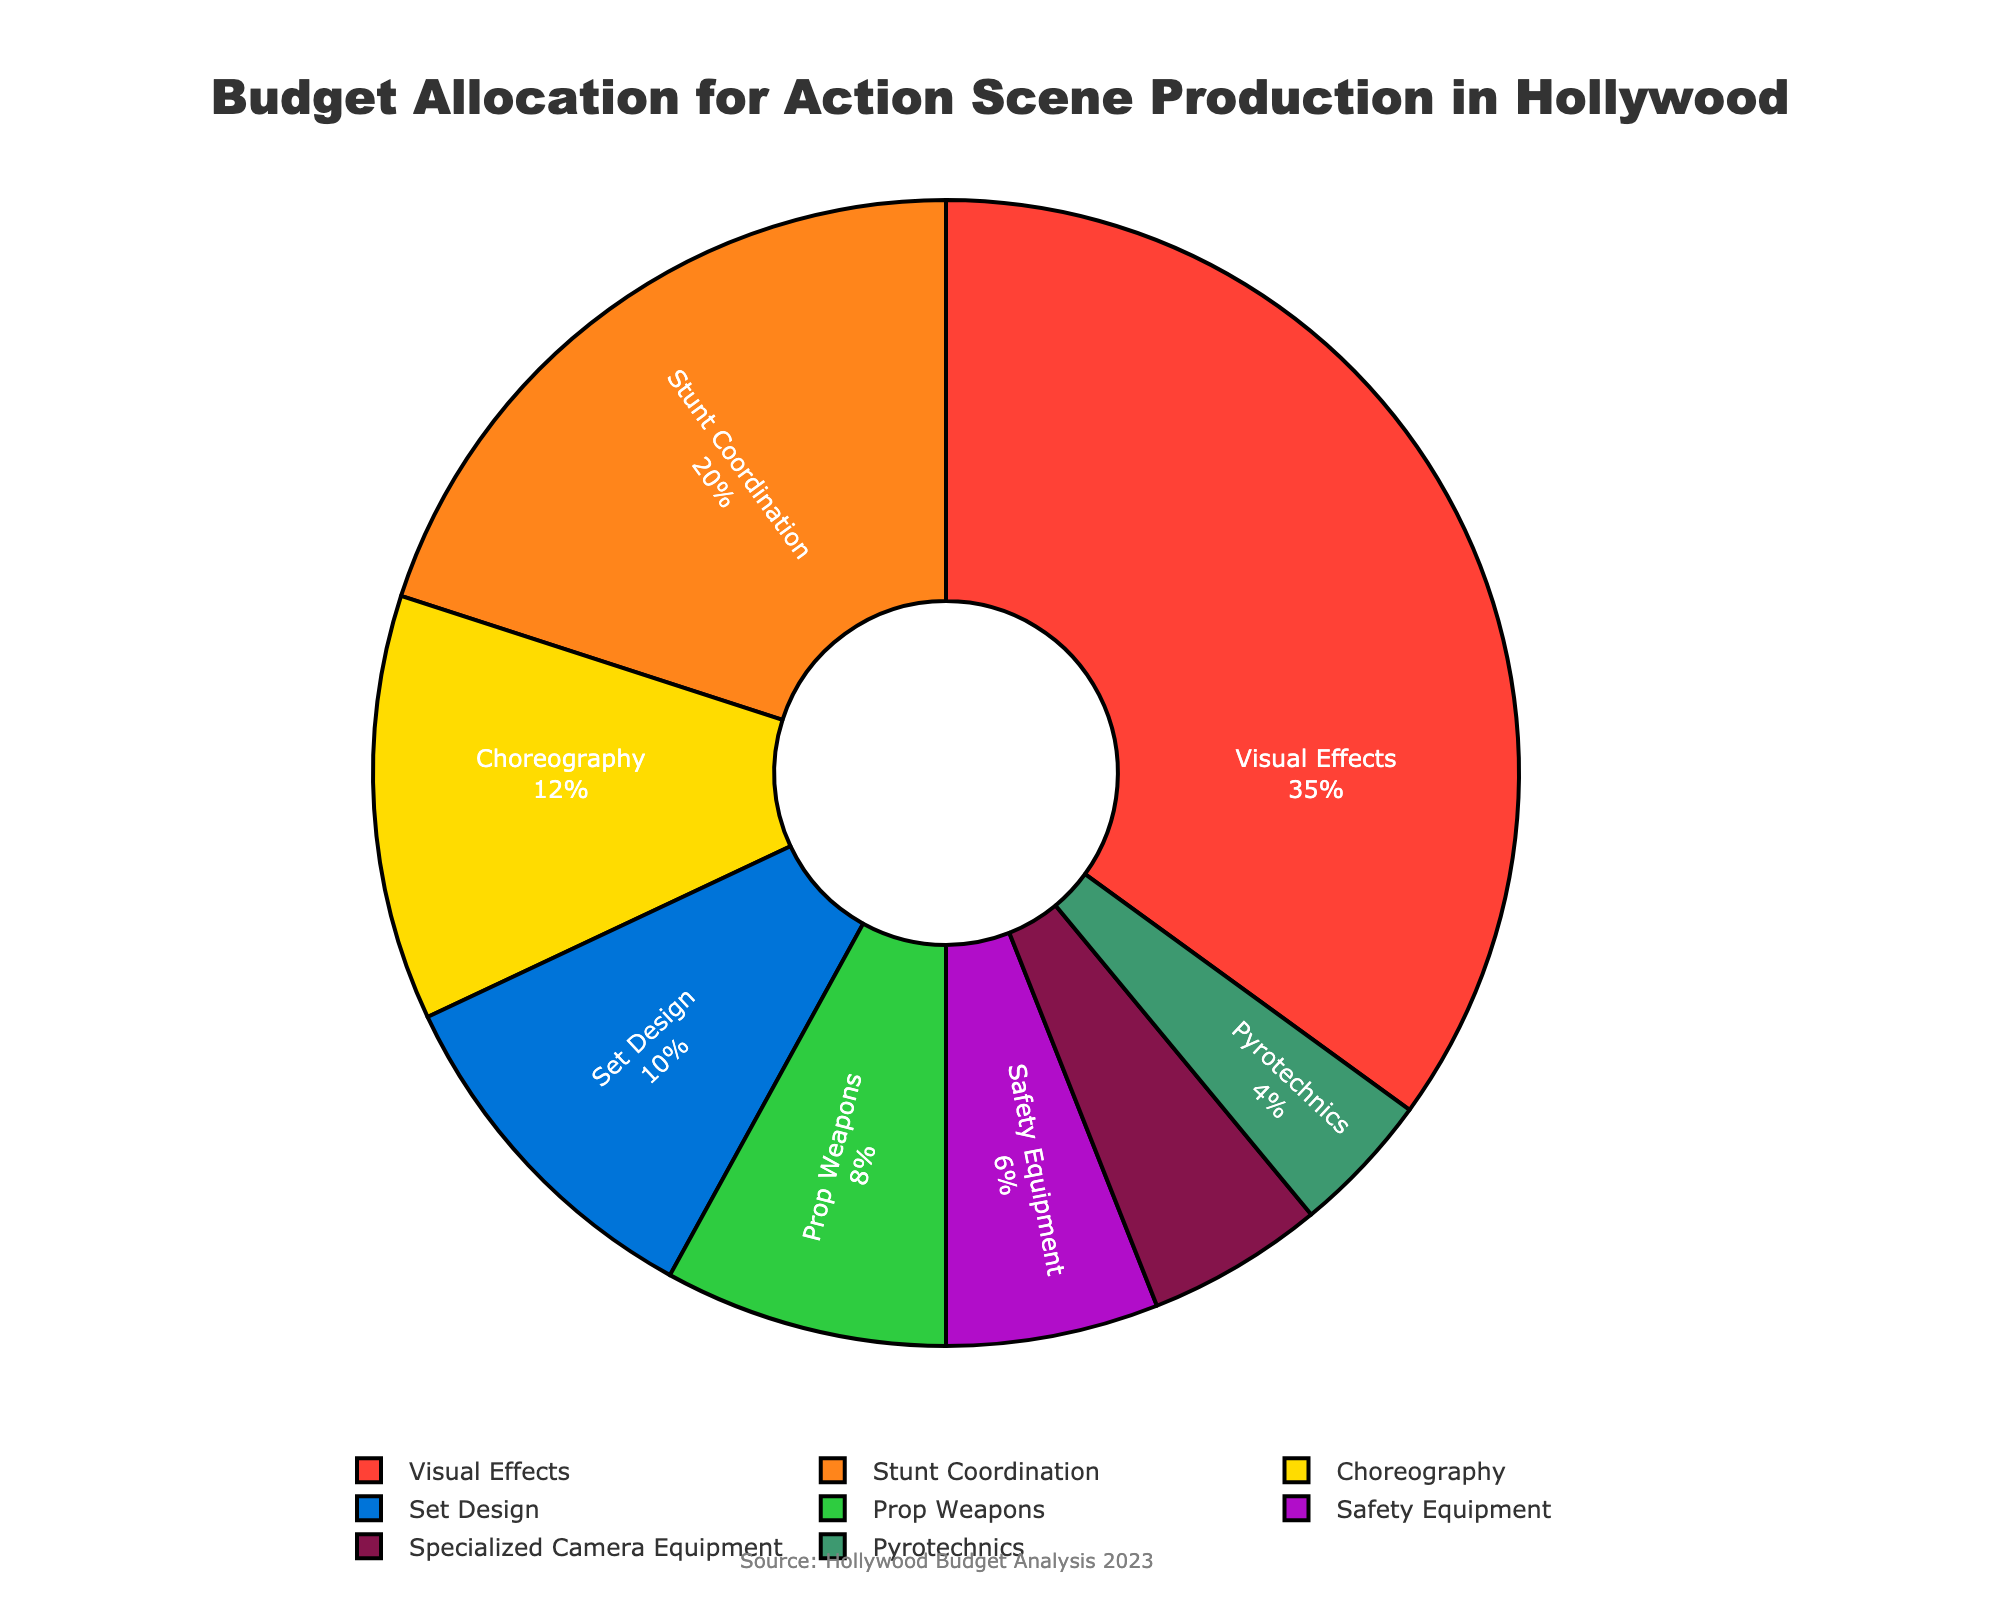What category has the highest budget allocation? Visual Effects has the largest slice of the pie chart. Its segment is labeled "35%", which is the highest percentage among all categories.
Answer: Visual Effects How much more budget is allocated to Visual Effects compared to Set Design? The budget for Visual Effects is 35%, and the budget for Set Design is 10%. The difference is 35% - 10% = 25%.
Answer: 25% What is the combined budget allocation for Stunt Coordination and Safety Equipment? The budget for Stunt Coordination is 20%, and for Safety Equipment, it is 6%. Summing these values gives 20% + 6% = 26%.
Answer: 26% Which two categories have the smallest budget allocations? Pyrotechnics and Specialized Camera Equipment have the smallest segments. Pyrotechnics is 4%, and Specialized Camera Equipment is 5%.
Answer: Pyrotechnics and Specialized Camera Equipment How does the budget for Choreography compare to Prop Weapons? Choreography has a segment labeled "12%", and Prop Weapons has a segment labeled "8%". Since 12% is greater than 8%, Choreography has a higher budget.
Answer: Choreography has a higher budget Is the combined budget for Choreography and Set Design higher than the budget for Visual Effects? The combined budget for Choreography (12%) and Set Design (10%) is 12% + 10% = 22%. The budget for Visual Effects is 35%, so 22% is less than 35%.
Answer: No What is the average budget allocation across all categories? Sum the percentages of all categories: 35 + 20 + 12 + 8 + 10 + 6 + 5 + 4 = 100. There are 8 categories, so the average allocation is 100 / 8 = 12.5%.
Answer: 12.5% What two categories together make up 40% of the budget allocation? Visual Effects is 35%, and Stunt Coordination is 20%. Together, they make up 35% + 20% = 55%. Thus, the next highest category, which is Set Design (10%), makes 35% + 10% = 45%. When you sum Visual Effects and Specialized Camera Equipment, it is 35% + 5% = 40%.
Answer: Visual Effects and Specialized Camera Equipment Which category occupies a bright green segment in the pie chart? The bright green segment in the pie chart corresponds to Set Design, which is labeled with a 10% budget allocation.
Answer: Set Design 